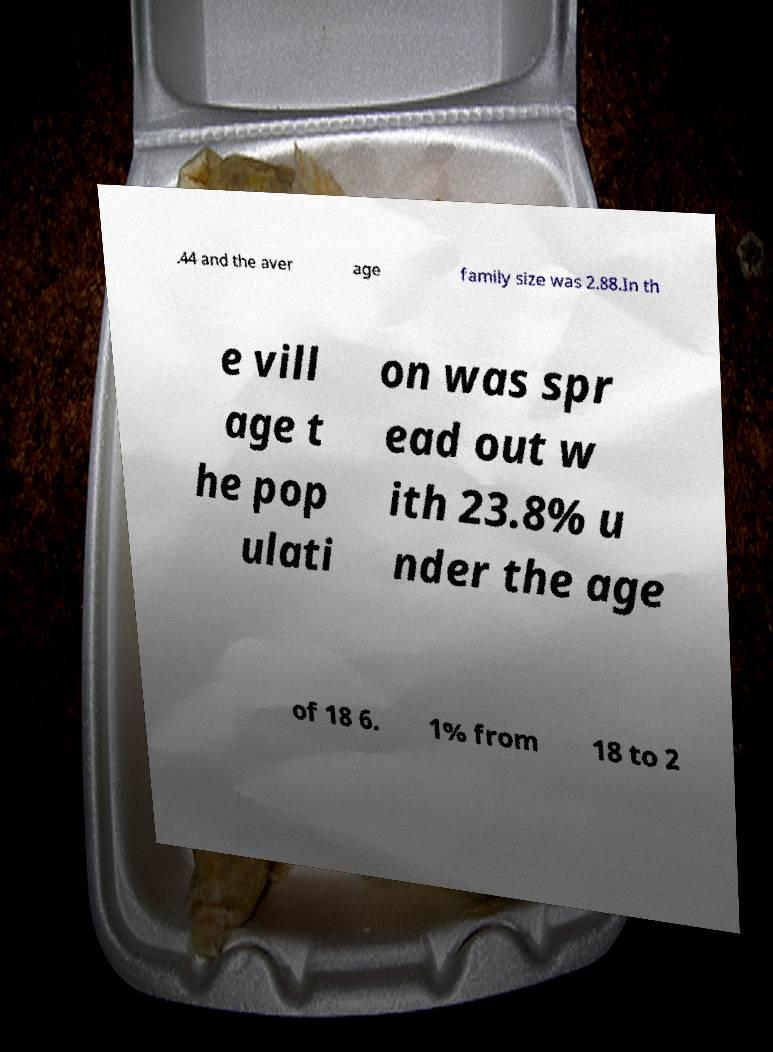Could you assist in decoding the text presented in this image and type it out clearly? .44 and the aver age family size was 2.88.In th e vill age t he pop ulati on was spr ead out w ith 23.8% u nder the age of 18 6. 1% from 18 to 2 